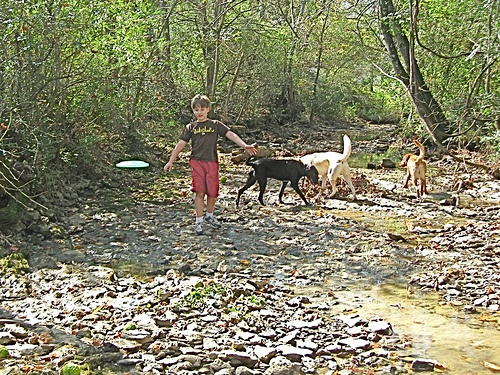Describe the objects in this image and their specific colors. I can see people in tan, brown, gray, and maroon tones, dog in tan, black, gray, and darkgray tones, dog in tan and white tones, dog in tan, beige, khaki, and maroon tones, and frisbee in tan, ivory, aquamarine, black, and darkgreen tones in this image. 